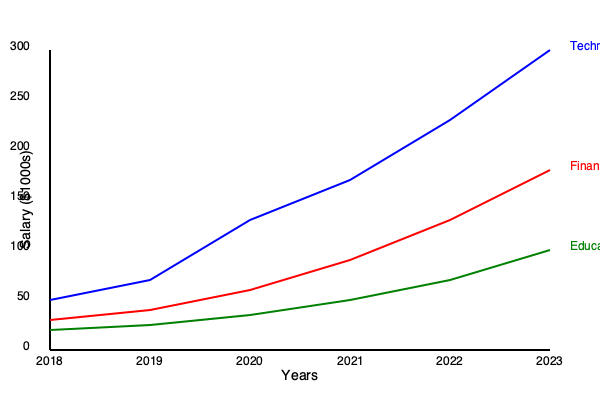Based on the line graph showing salary trends across different industries from 2018 to 2023, which industry has experienced the most significant salary growth, and what is the approximate percentage increase in its average salary over this period? To determine the industry with the most significant salary growth and calculate its percentage increase:

1. Identify the three industries: Technology (blue), Finance (red), and Education (green).

2. Compare the slopes of the lines:
   - Technology has the steepest slope, indicating the highest growth rate.
   - Finance has a moderate slope.
   - Education has the gentlest slope.

3. Calculate the percentage increase for Technology:
   a. Find the starting salary in 2018: approximately $50,000
   b. Find the ending salary in 2023: approximately $300,000
   c. Calculate the difference: $300,000 - $50,000 = $250,000
   d. Calculate the percentage increase:
      $\frac{\text{Increase}}{\text{Initial Value}} \times 100\% = \frac{250,000}{50,000} \times 100\% = 500\%$

Therefore, the Technology industry has experienced the most significant salary growth with an approximate 500% increase over the five-year period.
Answer: Technology, 500% 